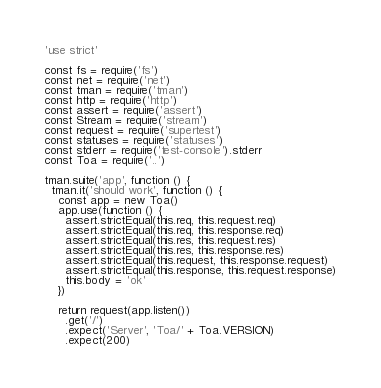<code> <loc_0><loc_0><loc_500><loc_500><_JavaScript_>'use strict'

const fs = require('fs')
const net = require('net')
const tman = require('tman')
const http = require('http')
const assert = require('assert')
const Stream = require('stream')
const request = require('supertest')
const statuses = require('statuses')
const stderr = require('test-console').stderr
const Toa = require('..')

tman.suite('app', function () {
  tman.it('should work', function () {
    const app = new Toa()
    app.use(function () {
      assert.strictEqual(this.req, this.request.req)
      assert.strictEqual(this.req, this.response.req)
      assert.strictEqual(this.res, this.request.res)
      assert.strictEqual(this.res, this.response.res)
      assert.strictEqual(this.request, this.response.request)
      assert.strictEqual(this.response, this.request.response)
      this.body = 'ok'
    })

    return request(app.listen())
      .get('/')
      .expect('Server', 'Toa/' + Toa.VERSION)
      .expect(200)</code> 